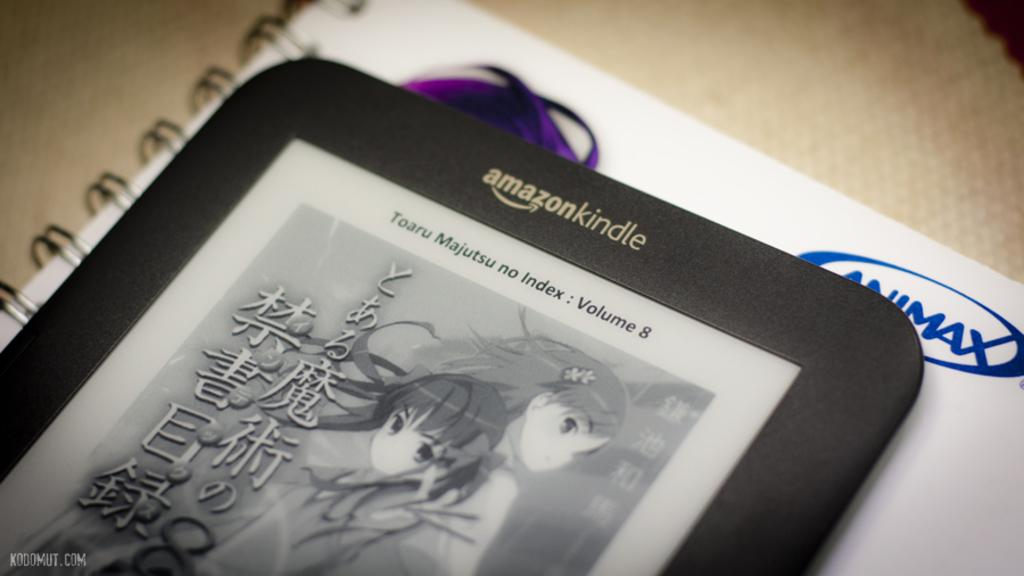<image>
Offer a succinct explanation of the picture presented. A manga displayed on a Amazon Kindle in black and white. 